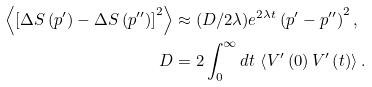Convert formula to latex. <formula><loc_0><loc_0><loc_500><loc_500>\left \langle \left [ \Delta S \left ( p ^ { \prime } \right ) - \Delta S \left ( p ^ { \prime \prime } \right ) \right ] ^ { 2 } \right \rangle & \approx ( D / 2 \lambda ) e ^ { 2 \lambda t } \left ( p ^ { \prime } - p ^ { \prime \prime } \right ) ^ { 2 } , \\ D & = 2 \int _ { 0 } ^ { \infty } d t \, \left \langle V ^ { \prime } \left ( 0 \right ) V ^ { \prime } \left ( t \right ) \right \rangle .</formula> 